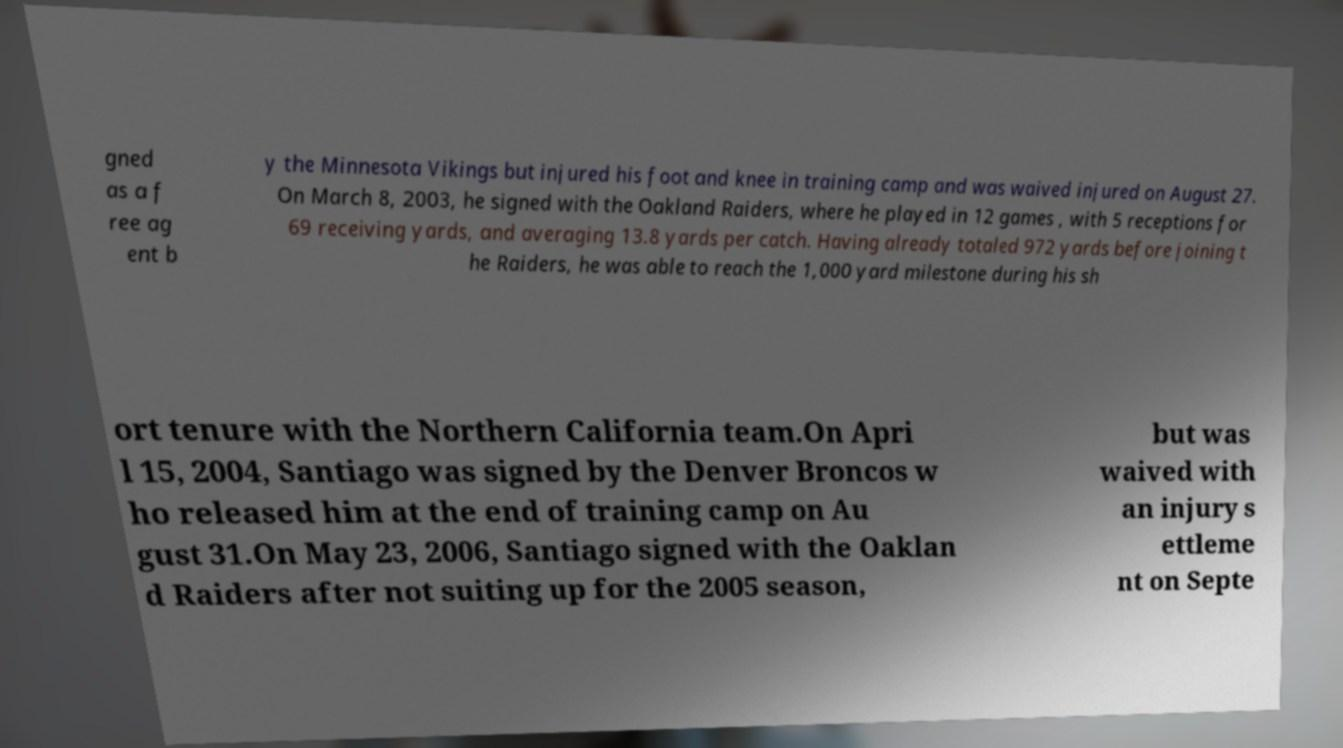For documentation purposes, I need the text within this image transcribed. Could you provide that? gned as a f ree ag ent b y the Minnesota Vikings but injured his foot and knee in training camp and was waived injured on August 27. On March 8, 2003, he signed with the Oakland Raiders, where he played in 12 games , with 5 receptions for 69 receiving yards, and averaging 13.8 yards per catch. Having already totaled 972 yards before joining t he Raiders, he was able to reach the 1,000 yard milestone during his sh ort tenure with the Northern California team.On Apri l 15, 2004, Santiago was signed by the Denver Broncos w ho released him at the end of training camp on Au gust 31.On May 23, 2006, Santiago signed with the Oaklan d Raiders after not suiting up for the 2005 season, but was waived with an injury s ettleme nt on Septe 